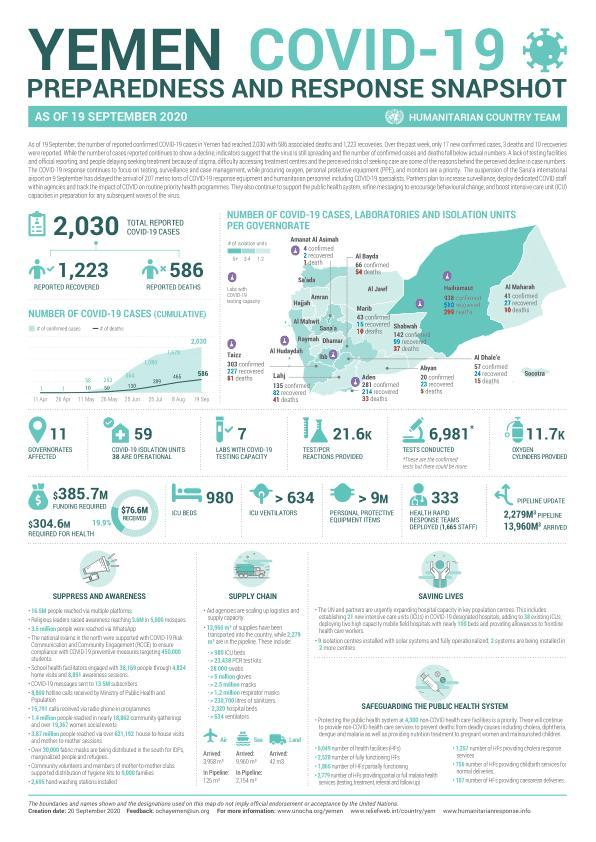What is the number of recovered?
Answer the question with a short phrase. 1,223 What is the number of ICU beds? 980 What is the number of reported cases? 586 What is the number of labs with covid-19 testing capacity? 7 